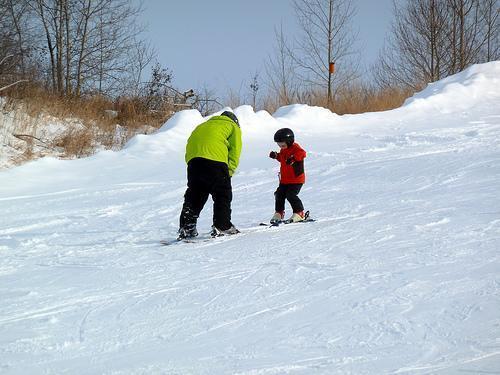How many people are wearing a red jacket in the image?
Give a very brief answer. 1. 